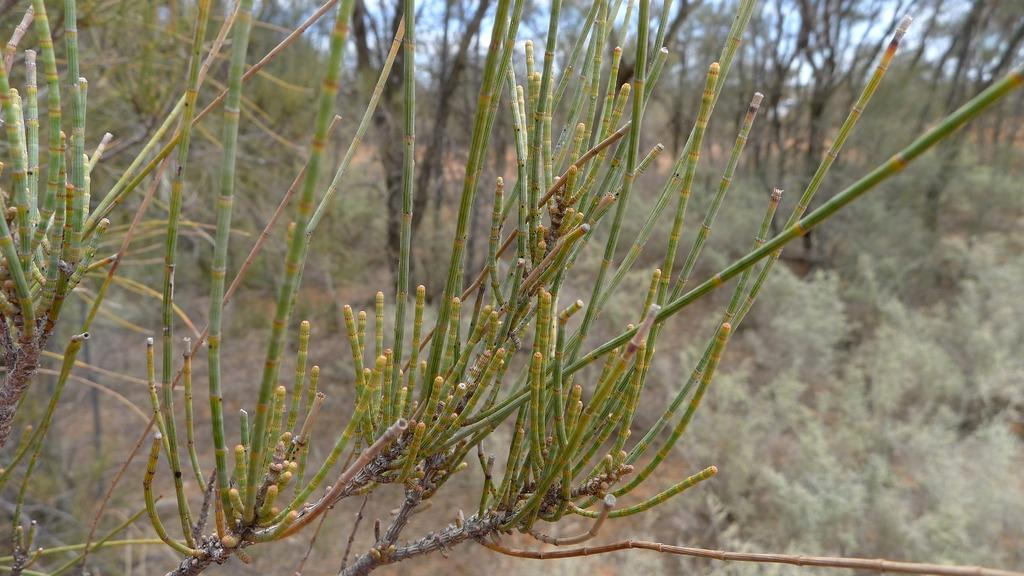What type of vegetation can be seen in the image? There are branches of trees in the image. What is visible in the background of the image? There are trees in the background of the image. How many apples can be seen on the calculator in the image? There is no calculator or apples present in the image. 